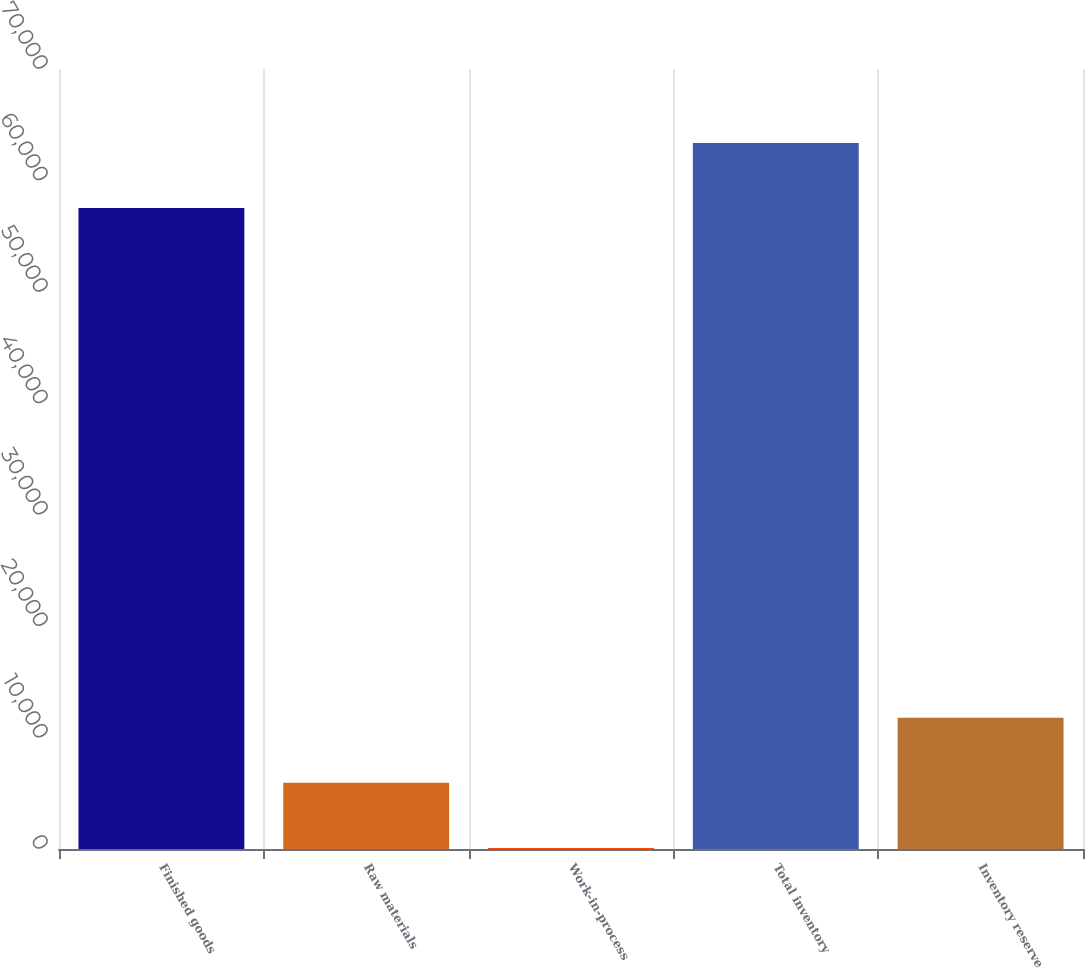Convert chart. <chart><loc_0><loc_0><loc_500><loc_500><bar_chart><fcel>Finished goods<fcel>Raw materials<fcel>Work-in-process<fcel>Total inventory<fcel>Inventory reserve<nl><fcel>57518<fcel>5934.9<fcel>95<fcel>63357.9<fcel>11774.8<nl></chart> 